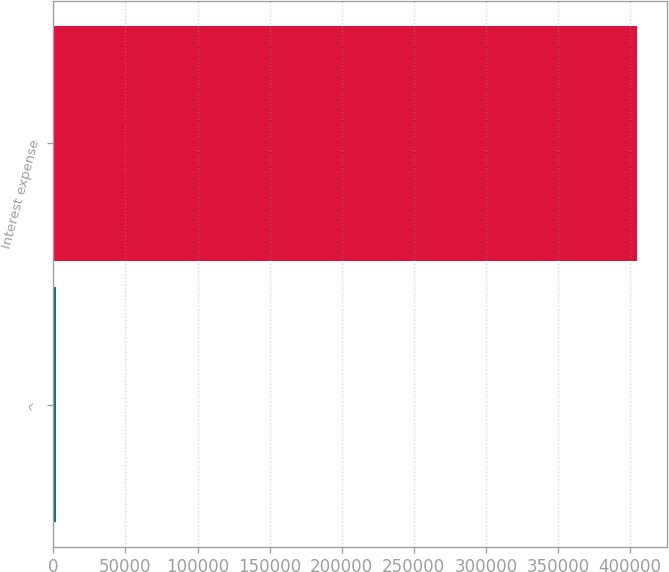Convert chart. <chart><loc_0><loc_0><loc_500><loc_500><bar_chart><fcel>^<fcel>Interest expense<nl><fcel>2015<fcel>405169<nl></chart> 